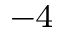Convert formula to latex. <formula><loc_0><loc_0><loc_500><loc_500>^ { - 4 }</formula> 